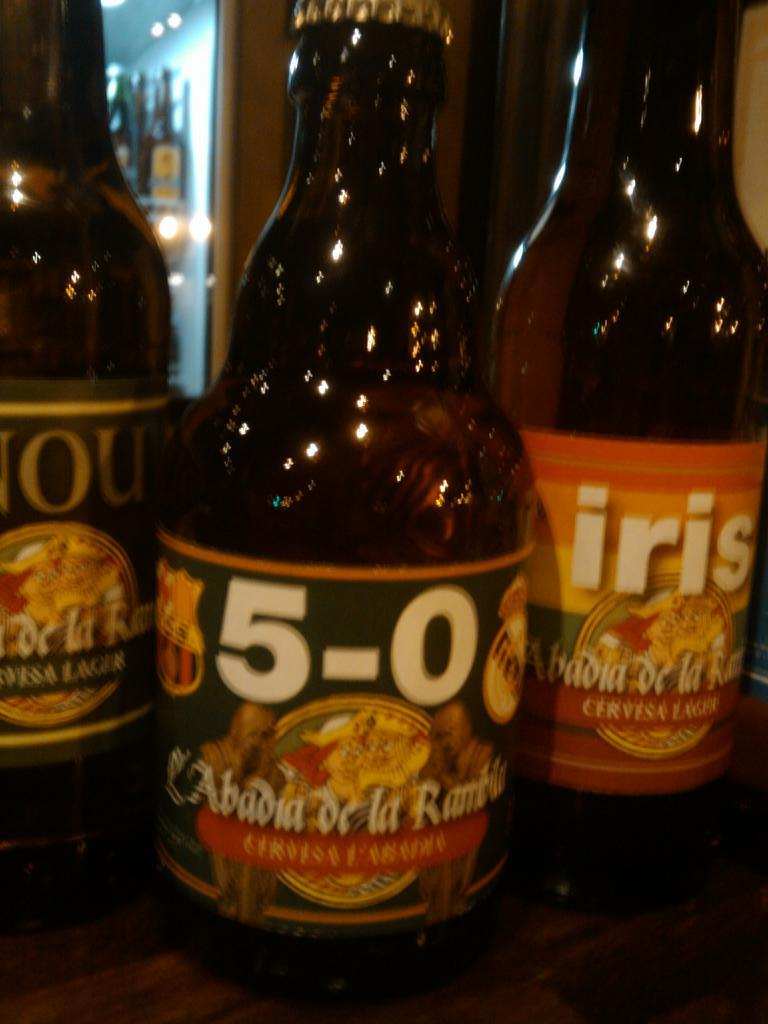<image>
Offer a succinct explanation of the picture presented. three bottles of 5-0 and Iris Cervesa Lager 